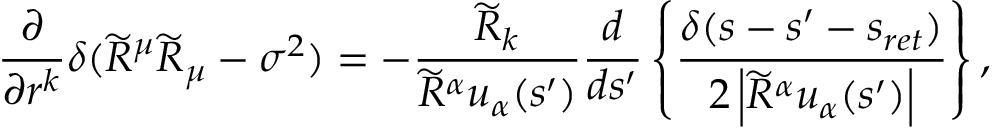<formula> <loc_0><loc_0><loc_500><loc_500>\frac { \partial } { \partial r ^ { k } } \delta ( \widetilde { R } ^ { \mu } \widetilde { R } _ { \mu } - \sigma ^ { 2 } ) = - \frac { \widetilde { R } _ { k } } { \widetilde { R } ^ { \alpha } u _ { \alpha } ( s ^ { \prime } ) } \frac { d } { d s ^ { \prime } } \left \{ \frac { \delta ( s - s ^ { \prime } - s _ { r e t } ) } { 2 \left | \widetilde { R } ^ { \alpha } u _ { \alpha } ( s ^ { \prime } ) \right | } \right \} ,</formula> 